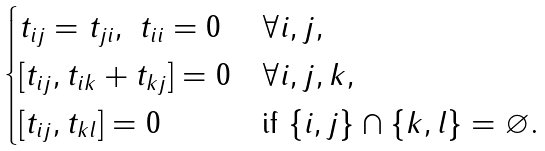<formula> <loc_0><loc_0><loc_500><loc_500>\begin{cases} t _ { i j } = t _ { j i } , \ t _ { i i } = 0 & \forall i , j , \\ [ t _ { i j } , t _ { i k } + t _ { k j } ] = 0 & \forall i , j , k , \\ [ t _ { i j } , t _ { k l } ] = 0 & \text {if } \{ i , j \} \cap \{ k , l \} = \varnothing . \end{cases}</formula> 